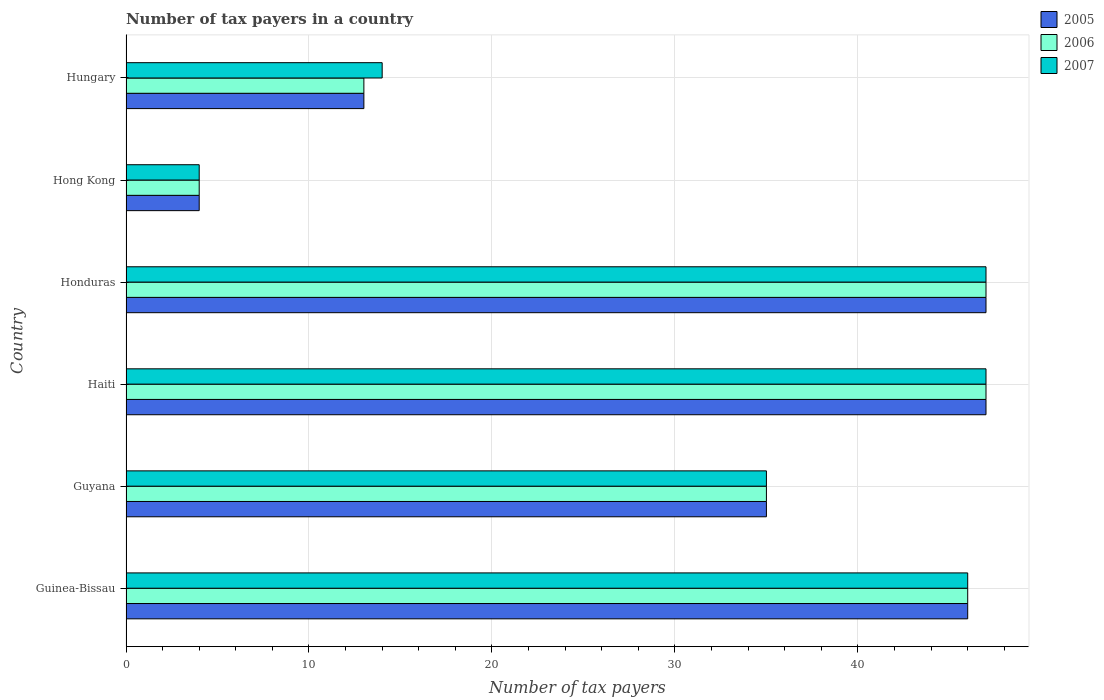How many different coloured bars are there?
Keep it short and to the point. 3. How many bars are there on the 5th tick from the bottom?
Provide a short and direct response. 3. What is the label of the 2nd group of bars from the top?
Provide a succinct answer. Hong Kong. In how many cases, is the number of bars for a given country not equal to the number of legend labels?
Your response must be concise. 0. What is the number of tax payers in in 2007 in Guyana?
Your answer should be very brief. 35. Across all countries, what is the maximum number of tax payers in in 2005?
Keep it short and to the point. 47. In which country was the number of tax payers in in 2006 maximum?
Offer a very short reply. Haiti. In which country was the number of tax payers in in 2007 minimum?
Your answer should be compact. Hong Kong. What is the total number of tax payers in in 2005 in the graph?
Provide a short and direct response. 192. What is the difference between the number of tax payers in in 2006 in Guyana and that in Hungary?
Give a very brief answer. 22. What is the average number of tax payers in in 2005 per country?
Your response must be concise. 32. What is the ratio of the number of tax payers in in 2007 in Guyana to that in Hong Kong?
Offer a very short reply. 8.75. Is the number of tax payers in in 2006 in Guinea-Bissau less than that in Guyana?
Provide a succinct answer. No. Is the difference between the number of tax payers in in 2006 in Guinea-Bissau and Honduras greater than the difference between the number of tax payers in in 2007 in Guinea-Bissau and Honduras?
Offer a very short reply. No. What is the difference between the highest and the second highest number of tax payers in in 2005?
Make the answer very short. 0. What is the difference between the highest and the lowest number of tax payers in in 2007?
Your answer should be compact. 43. In how many countries, is the number of tax payers in in 2006 greater than the average number of tax payers in in 2006 taken over all countries?
Offer a terse response. 4. What does the 3rd bar from the bottom in Hong Kong represents?
Provide a short and direct response. 2007. Is it the case that in every country, the sum of the number of tax payers in in 2006 and number of tax payers in in 2007 is greater than the number of tax payers in in 2005?
Your answer should be very brief. Yes. How many bars are there?
Keep it short and to the point. 18. How many countries are there in the graph?
Give a very brief answer. 6. What is the difference between two consecutive major ticks on the X-axis?
Give a very brief answer. 10. Are the values on the major ticks of X-axis written in scientific E-notation?
Your answer should be compact. No. Where does the legend appear in the graph?
Offer a terse response. Top right. How many legend labels are there?
Keep it short and to the point. 3. How are the legend labels stacked?
Your answer should be very brief. Vertical. What is the title of the graph?
Your response must be concise. Number of tax payers in a country. What is the label or title of the X-axis?
Offer a very short reply. Number of tax payers. What is the Number of tax payers in 2005 in Guinea-Bissau?
Your response must be concise. 46. What is the Number of tax payers in 2006 in Guyana?
Your response must be concise. 35. What is the Number of tax payers in 2005 in Haiti?
Give a very brief answer. 47. What is the Number of tax payers of 2006 in Haiti?
Provide a succinct answer. 47. What is the Number of tax payers in 2005 in Honduras?
Provide a short and direct response. 47. What is the Number of tax payers in 2007 in Honduras?
Offer a terse response. 47. What is the Number of tax payers of 2006 in Hong Kong?
Your response must be concise. 4. What is the Number of tax payers of 2007 in Hong Kong?
Ensure brevity in your answer.  4. What is the Number of tax payers in 2005 in Hungary?
Your response must be concise. 13. What is the Number of tax payers in 2006 in Hungary?
Give a very brief answer. 13. Across all countries, what is the maximum Number of tax payers in 2005?
Your response must be concise. 47. Across all countries, what is the minimum Number of tax payers in 2005?
Give a very brief answer. 4. Across all countries, what is the minimum Number of tax payers of 2006?
Offer a terse response. 4. What is the total Number of tax payers in 2005 in the graph?
Your response must be concise. 192. What is the total Number of tax payers in 2006 in the graph?
Your answer should be very brief. 192. What is the total Number of tax payers in 2007 in the graph?
Give a very brief answer. 193. What is the difference between the Number of tax payers in 2006 in Guinea-Bissau and that in Guyana?
Your response must be concise. 11. What is the difference between the Number of tax payers of 2007 in Guinea-Bissau and that in Guyana?
Your response must be concise. 11. What is the difference between the Number of tax payers of 2007 in Guinea-Bissau and that in Honduras?
Offer a very short reply. -1. What is the difference between the Number of tax payers of 2005 in Guinea-Bissau and that in Hong Kong?
Offer a very short reply. 42. What is the difference between the Number of tax payers in 2006 in Guinea-Bissau and that in Hungary?
Ensure brevity in your answer.  33. What is the difference between the Number of tax payers in 2007 in Guinea-Bissau and that in Hungary?
Your answer should be very brief. 32. What is the difference between the Number of tax payers in 2005 in Guyana and that in Haiti?
Offer a terse response. -12. What is the difference between the Number of tax payers of 2006 in Guyana and that in Haiti?
Give a very brief answer. -12. What is the difference between the Number of tax payers of 2007 in Guyana and that in Haiti?
Ensure brevity in your answer.  -12. What is the difference between the Number of tax payers in 2005 in Guyana and that in Hong Kong?
Provide a short and direct response. 31. What is the difference between the Number of tax payers in 2006 in Guyana and that in Hong Kong?
Provide a succinct answer. 31. What is the difference between the Number of tax payers of 2005 in Haiti and that in Honduras?
Your response must be concise. 0. What is the difference between the Number of tax payers of 2006 in Haiti and that in Honduras?
Your answer should be very brief. 0. What is the difference between the Number of tax payers in 2007 in Haiti and that in Honduras?
Make the answer very short. 0. What is the difference between the Number of tax payers in 2005 in Haiti and that in Hong Kong?
Your answer should be compact. 43. What is the difference between the Number of tax payers of 2007 in Haiti and that in Hong Kong?
Your response must be concise. 43. What is the difference between the Number of tax payers of 2005 in Haiti and that in Hungary?
Your answer should be very brief. 34. What is the difference between the Number of tax payers in 2006 in Haiti and that in Hungary?
Provide a short and direct response. 34. What is the difference between the Number of tax payers in 2006 in Honduras and that in Hong Kong?
Offer a very short reply. 43. What is the difference between the Number of tax payers of 2006 in Honduras and that in Hungary?
Your answer should be very brief. 34. What is the difference between the Number of tax payers of 2007 in Honduras and that in Hungary?
Your answer should be very brief. 33. What is the difference between the Number of tax payers of 2005 in Hong Kong and that in Hungary?
Offer a very short reply. -9. What is the difference between the Number of tax payers in 2005 in Guinea-Bissau and the Number of tax payers in 2006 in Guyana?
Make the answer very short. 11. What is the difference between the Number of tax payers of 2006 in Guinea-Bissau and the Number of tax payers of 2007 in Guyana?
Offer a very short reply. 11. What is the difference between the Number of tax payers in 2005 in Guinea-Bissau and the Number of tax payers in 2006 in Honduras?
Offer a terse response. -1. What is the difference between the Number of tax payers in 2006 in Guinea-Bissau and the Number of tax payers in 2007 in Honduras?
Ensure brevity in your answer.  -1. What is the difference between the Number of tax payers in 2005 in Guinea-Bissau and the Number of tax payers in 2007 in Hungary?
Your response must be concise. 32. What is the difference between the Number of tax payers in 2005 in Guyana and the Number of tax payers in 2007 in Haiti?
Ensure brevity in your answer.  -12. What is the difference between the Number of tax payers in 2005 in Guyana and the Number of tax payers in 2007 in Honduras?
Provide a succinct answer. -12. What is the difference between the Number of tax payers in 2006 in Guyana and the Number of tax payers in 2007 in Honduras?
Your response must be concise. -12. What is the difference between the Number of tax payers in 2005 in Guyana and the Number of tax payers in 2006 in Hong Kong?
Give a very brief answer. 31. What is the difference between the Number of tax payers in 2005 in Guyana and the Number of tax payers in 2006 in Hungary?
Your response must be concise. 22. What is the difference between the Number of tax payers of 2006 in Haiti and the Number of tax payers of 2007 in Honduras?
Make the answer very short. 0. What is the difference between the Number of tax payers in 2005 in Haiti and the Number of tax payers in 2007 in Hong Kong?
Offer a very short reply. 43. What is the difference between the Number of tax payers of 2006 in Haiti and the Number of tax payers of 2007 in Hong Kong?
Make the answer very short. 43. What is the difference between the Number of tax payers in 2005 in Haiti and the Number of tax payers in 2006 in Hungary?
Offer a terse response. 34. What is the difference between the Number of tax payers of 2005 in Honduras and the Number of tax payers of 2007 in Hong Kong?
Give a very brief answer. 43. What is the difference between the Number of tax payers of 2006 in Hong Kong and the Number of tax payers of 2007 in Hungary?
Offer a terse response. -10. What is the average Number of tax payers in 2005 per country?
Your answer should be very brief. 32. What is the average Number of tax payers of 2006 per country?
Offer a terse response. 32. What is the average Number of tax payers of 2007 per country?
Your response must be concise. 32.17. What is the difference between the Number of tax payers in 2005 and Number of tax payers in 2007 in Guinea-Bissau?
Keep it short and to the point. 0. What is the difference between the Number of tax payers in 2005 and Number of tax payers in 2006 in Guyana?
Give a very brief answer. 0. What is the difference between the Number of tax payers in 2006 and Number of tax payers in 2007 in Guyana?
Your answer should be compact. 0. What is the difference between the Number of tax payers of 2005 and Number of tax payers of 2007 in Haiti?
Your answer should be compact. 0. What is the difference between the Number of tax payers of 2006 and Number of tax payers of 2007 in Haiti?
Your answer should be very brief. 0. What is the difference between the Number of tax payers of 2005 and Number of tax payers of 2006 in Honduras?
Keep it short and to the point. 0. What is the difference between the Number of tax payers in 2005 and Number of tax payers in 2006 in Hungary?
Provide a short and direct response. 0. What is the difference between the Number of tax payers of 2005 and Number of tax payers of 2007 in Hungary?
Offer a very short reply. -1. What is the difference between the Number of tax payers in 2006 and Number of tax payers in 2007 in Hungary?
Keep it short and to the point. -1. What is the ratio of the Number of tax payers of 2005 in Guinea-Bissau to that in Guyana?
Your answer should be very brief. 1.31. What is the ratio of the Number of tax payers of 2006 in Guinea-Bissau to that in Guyana?
Give a very brief answer. 1.31. What is the ratio of the Number of tax payers in 2007 in Guinea-Bissau to that in Guyana?
Provide a short and direct response. 1.31. What is the ratio of the Number of tax payers in 2005 in Guinea-Bissau to that in Haiti?
Keep it short and to the point. 0.98. What is the ratio of the Number of tax payers of 2006 in Guinea-Bissau to that in Haiti?
Offer a terse response. 0.98. What is the ratio of the Number of tax payers of 2007 in Guinea-Bissau to that in Haiti?
Ensure brevity in your answer.  0.98. What is the ratio of the Number of tax payers in 2005 in Guinea-Bissau to that in Honduras?
Keep it short and to the point. 0.98. What is the ratio of the Number of tax payers of 2006 in Guinea-Bissau to that in Honduras?
Ensure brevity in your answer.  0.98. What is the ratio of the Number of tax payers of 2007 in Guinea-Bissau to that in Honduras?
Provide a short and direct response. 0.98. What is the ratio of the Number of tax payers of 2005 in Guinea-Bissau to that in Hong Kong?
Make the answer very short. 11.5. What is the ratio of the Number of tax payers in 2006 in Guinea-Bissau to that in Hong Kong?
Offer a terse response. 11.5. What is the ratio of the Number of tax payers of 2005 in Guinea-Bissau to that in Hungary?
Offer a very short reply. 3.54. What is the ratio of the Number of tax payers in 2006 in Guinea-Bissau to that in Hungary?
Your response must be concise. 3.54. What is the ratio of the Number of tax payers of 2007 in Guinea-Bissau to that in Hungary?
Offer a terse response. 3.29. What is the ratio of the Number of tax payers of 2005 in Guyana to that in Haiti?
Give a very brief answer. 0.74. What is the ratio of the Number of tax payers in 2006 in Guyana to that in Haiti?
Offer a very short reply. 0.74. What is the ratio of the Number of tax payers of 2007 in Guyana to that in Haiti?
Make the answer very short. 0.74. What is the ratio of the Number of tax payers in 2005 in Guyana to that in Honduras?
Your answer should be very brief. 0.74. What is the ratio of the Number of tax payers of 2006 in Guyana to that in Honduras?
Your response must be concise. 0.74. What is the ratio of the Number of tax payers in 2007 in Guyana to that in Honduras?
Ensure brevity in your answer.  0.74. What is the ratio of the Number of tax payers in 2005 in Guyana to that in Hong Kong?
Your answer should be very brief. 8.75. What is the ratio of the Number of tax payers in 2006 in Guyana to that in Hong Kong?
Give a very brief answer. 8.75. What is the ratio of the Number of tax payers in 2007 in Guyana to that in Hong Kong?
Offer a very short reply. 8.75. What is the ratio of the Number of tax payers in 2005 in Guyana to that in Hungary?
Make the answer very short. 2.69. What is the ratio of the Number of tax payers in 2006 in Guyana to that in Hungary?
Offer a very short reply. 2.69. What is the ratio of the Number of tax payers in 2006 in Haiti to that in Honduras?
Give a very brief answer. 1. What is the ratio of the Number of tax payers of 2007 in Haiti to that in Honduras?
Your answer should be very brief. 1. What is the ratio of the Number of tax payers in 2005 in Haiti to that in Hong Kong?
Make the answer very short. 11.75. What is the ratio of the Number of tax payers in 2006 in Haiti to that in Hong Kong?
Give a very brief answer. 11.75. What is the ratio of the Number of tax payers in 2007 in Haiti to that in Hong Kong?
Provide a short and direct response. 11.75. What is the ratio of the Number of tax payers in 2005 in Haiti to that in Hungary?
Provide a short and direct response. 3.62. What is the ratio of the Number of tax payers of 2006 in Haiti to that in Hungary?
Give a very brief answer. 3.62. What is the ratio of the Number of tax payers of 2007 in Haiti to that in Hungary?
Provide a succinct answer. 3.36. What is the ratio of the Number of tax payers in 2005 in Honduras to that in Hong Kong?
Make the answer very short. 11.75. What is the ratio of the Number of tax payers of 2006 in Honduras to that in Hong Kong?
Ensure brevity in your answer.  11.75. What is the ratio of the Number of tax payers of 2007 in Honduras to that in Hong Kong?
Provide a succinct answer. 11.75. What is the ratio of the Number of tax payers in 2005 in Honduras to that in Hungary?
Your answer should be very brief. 3.62. What is the ratio of the Number of tax payers in 2006 in Honduras to that in Hungary?
Your response must be concise. 3.62. What is the ratio of the Number of tax payers in 2007 in Honduras to that in Hungary?
Your response must be concise. 3.36. What is the ratio of the Number of tax payers in 2005 in Hong Kong to that in Hungary?
Offer a very short reply. 0.31. What is the ratio of the Number of tax payers of 2006 in Hong Kong to that in Hungary?
Provide a succinct answer. 0.31. What is the ratio of the Number of tax payers in 2007 in Hong Kong to that in Hungary?
Your answer should be very brief. 0.29. What is the difference between the highest and the second highest Number of tax payers of 2005?
Ensure brevity in your answer.  0. What is the difference between the highest and the second highest Number of tax payers in 2006?
Offer a very short reply. 0. What is the difference between the highest and the lowest Number of tax payers of 2005?
Provide a succinct answer. 43. What is the difference between the highest and the lowest Number of tax payers in 2006?
Provide a short and direct response. 43. 